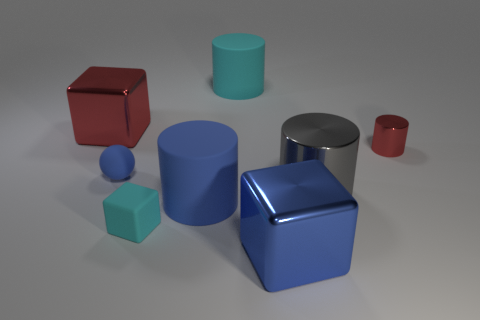Do the large blue matte object and the big cyan thing have the same shape?
Provide a short and direct response. Yes. How many red cubes are made of the same material as the big gray thing?
Your answer should be very brief. 1. There is a red metal thing that is the same shape as the small cyan thing; what size is it?
Your answer should be very brief. Large. Do the blue matte sphere and the gray shiny thing have the same size?
Provide a short and direct response. No. What is the shape of the red shiny object that is behind the red object that is in front of the metal thing to the left of the small blue matte thing?
Ensure brevity in your answer.  Cube. What is the color of the other metal object that is the same shape as the tiny red object?
Your answer should be very brief. Gray. There is a blue thing that is both in front of the gray metallic object and left of the cyan cylinder; what is its size?
Offer a very short reply. Large. How many blue metallic blocks are behind the large metallic cube behind the large metallic block that is right of the cyan cylinder?
Ensure brevity in your answer.  0. What number of large objects are either blue rubber spheres or red objects?
Keep it short and to the point. 1. Is the material of the block behind the tiny cyan rubber thing the same as the small red cylinder?
Your answer should be compact. Yes. 